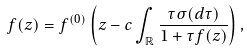Convert formula to latex. <formula><loc_0><loc_0><loc_500><loc_500>f ( z ) = f ^ { ( 0 ) } \left ( z - c \int _ { \mathbb { R } } \frac { \tau \sigma ( d \tau ) } { 1 + \tau f ( z ) } \right ) ,</formula> 